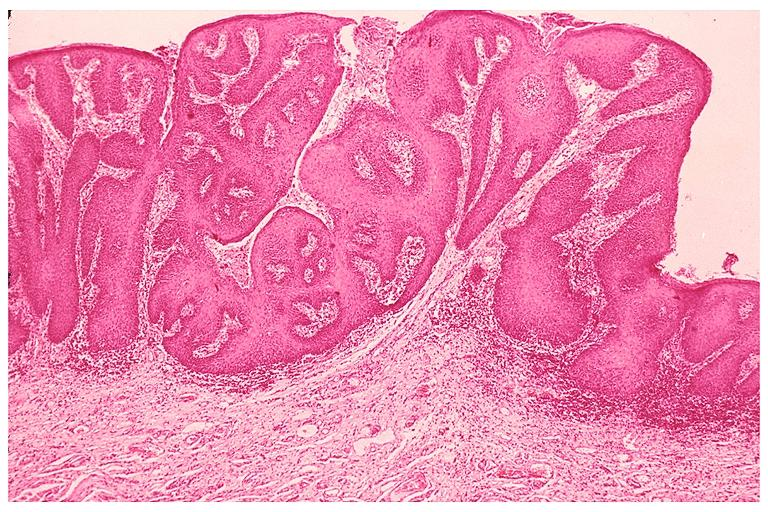what is present?
Answer the question using a single word or phrase. Oral 